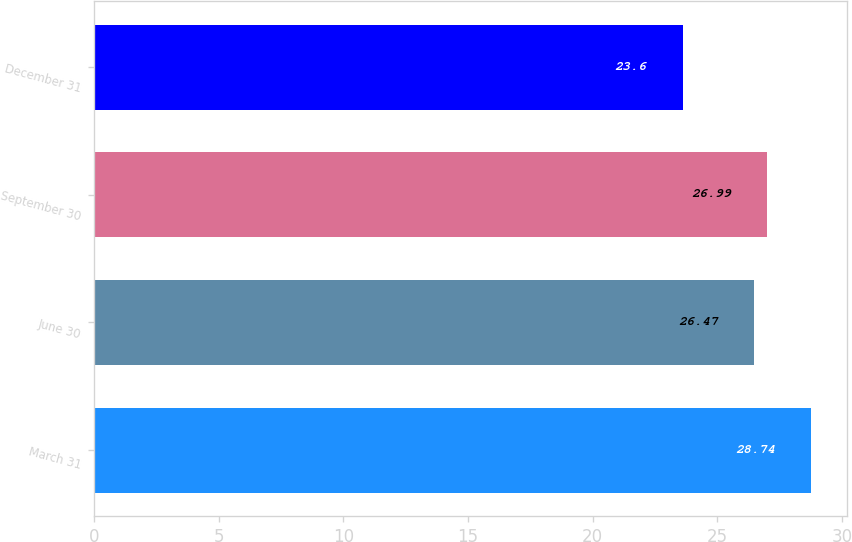<chart> <loc_0><loc_0><loc_500><loc_500><bar_chart><fcel>March 31<fcel>June 30<fcel>September 30<fcel>December 31<nl><fcel>28.74<fcel>26.47<fcel>26.99<fcel>23.6<nl></chart> 